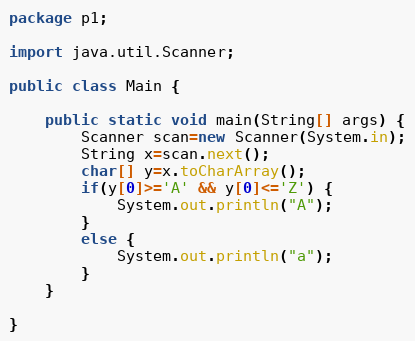Convert code to text. <code><loc_0><loc_0><loc_500><loc_500><_Java_>package p1;

import java.util.Scanner;

public class Main {

	public static void main(String[] args) {
		Scanner scan=new Scanner(System.in);
		String x=scan.next();
		char[] y=x.toCharArray();
		if(y[0]>='A' && y[0]<='Z') {
			System.out.println("A");
		}
		else {
			System.out.println("a");
		}
	}

}
</code> 